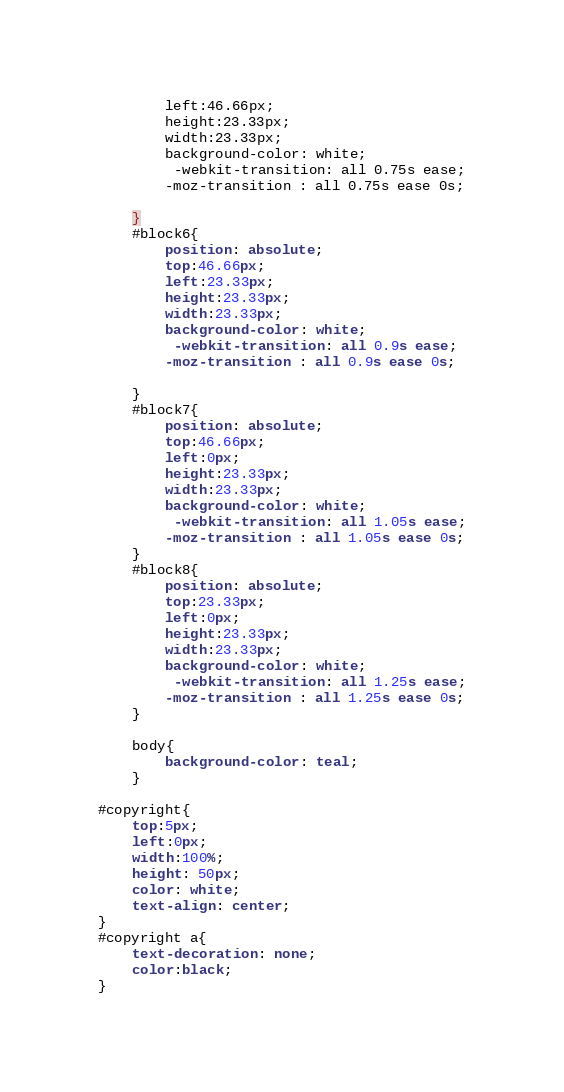Convert code to text. <code><loc_0><loc_0><loc_500><loc_500><_CSS_>        left:46.66px;
        height:23.33px;
        width:23.33px;
        background-color: white;
         -webkit-transition: all 0.75s ease;
        -moz-transition : all 0.75s ease 0s;
       
    }
    #block6{
        position: absolute;
        top:46.66px;
        left:23.33px;
        height:23.33px;
        width:23.33px;
        background-color: white;
         -webkit-transition: all 0.9s ease;
        -moz-transition : all 0.9s ease 0s;
       
    }
    #block7{
        position: absolute;
        top:46.66px;
        left:0px;
        height:23.33px;
        width:23.33px;
        background-color: white;
         -webkit-transition: all 1.05s ease;
        -moz-transition : all 1.05s ease 0s;
    }
    #block8{
        position: absolute;
        top:23.33px;
        left:0px;
        height:23.33px;
        width:23.33px;
        background-color: white;
         -webkit-transition: all 1.25s ease;
        -moz-transition : all 1.25s ease 0s;
    }
   
    body{
        background-color: teal;
    }
   
#copyright{
    top:5px;
    left:0px;
    width:100%;
    height: 50px;
    color: white;
    text-align: center;
}
#copyright a{
    text-decoration: none;
    color:black;
}</code> 